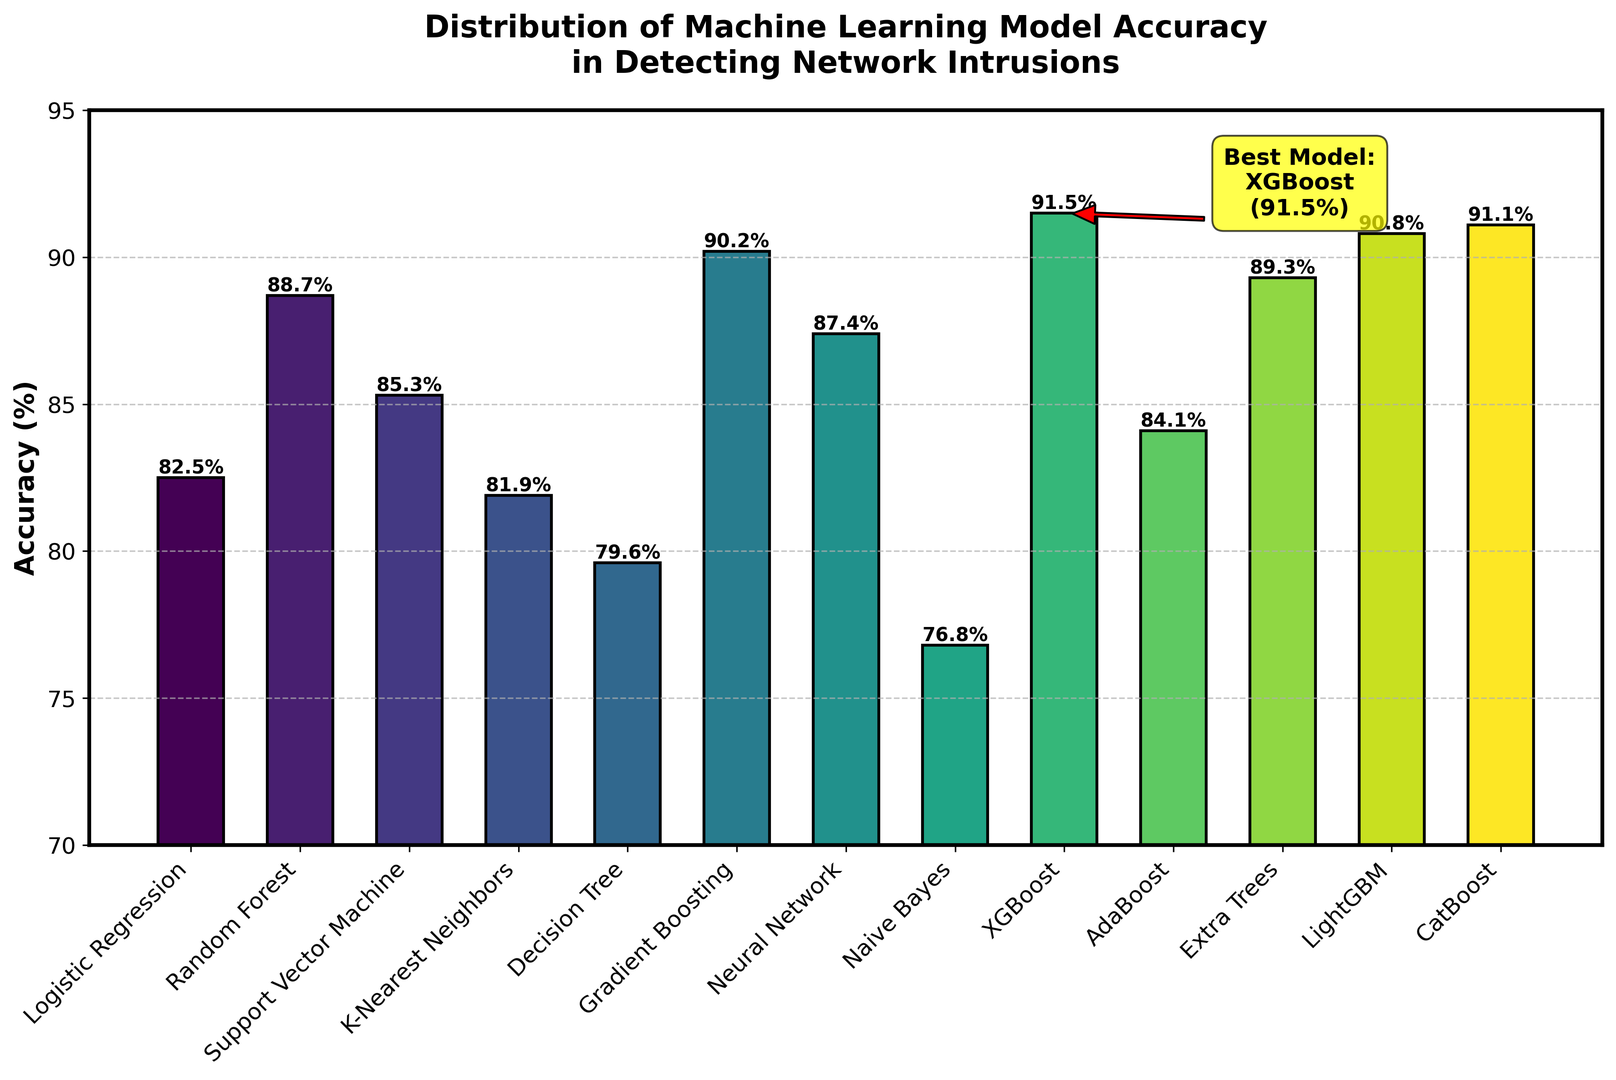Which machine learning model shows the highest accuracy in detecting network intrusions? The figure shows the accuracy for each model, and the annotation highlights the best-performing model. The bar for XGBoost is the tallest, and it's annotated as the best model.
Answer: XGBoost How much higher is the accuracy of XGBoost compared to Naive Bayes? The accuracy of XGBoost is 91.5% and the accuracy of Naive Bayes is 76.8%. The difference is calculated as 91.5% - 76.8%. This gives us the margin.
Answer: 14.7% Which models have an accuracy higher than 90%? By inspecting the figure, we can identify the models: Gradient Boosting (90.2%), XGBoost (91.5%), LightGBM (90.8%), and CatBoost (91.1%) all have accuracies above 90%.
Answer: Gradient Boosting, XGBoost, LightGBM, CatBoost What is the range of accuracies among all models? The range is calculated by subtracting the lowest accuracy from the highest accuracy represented in the figure. XGBoost has the highest accuracy of 91.5% and Naive Bayes has the lowest accuracy of 76.8%.
Answer: 14.7% Is the accuracy of Logistic Regression closer to Decision Tree or K-Nearest Neighbors? Comparing Logistic Regression (82.5%) with Decision Tree (79.6%) and K-Nearest Neighbors (81.9%), we calculate the differences: 82.5% - 79.6% = 2.9% and 82.5% - 81.9% = 0.6%. Logistic Regression is closer to K-Nearest Neighbors.
Answer: K-Nearest Neighbors What is the mean accuracy of all models? The mean can be found by summing all accuracies and dividing by the number of models. Sum = 82.5 + 88.7 + 85.3 + 81.9 + 79.6 + 90.2 + 87.4 + 76.8 + 91.5 + 84.1 + 89.3 + 90.8 + 91.1. There are 13 models, so divide the sum by 13.
Answer: 86.5% How does the accuracy of Neural Network compare to the average accuracy of all models? First, compute the average accuracy (86.5%). Neural Network has an accuracy of 87.4%. Comparing both values, 87.4% is slightly above the average.
Answer: Above average Which models have accuracy within 1% of Gradient Boosting? Gradient Boosting has an accuracy of 90.2%. Within a 1% range are models with accuracies between 89.2% and 91.2%. LightGBM (90.8%), CatBoost (91.1%), and Extra Trees (89.3%) fall within this range.
Answer: LightGBM, CatBoost, Extra Trees Between Random Forest and AdaBoost, which model has higher accuracy and by how much? Random Forest has an accuracy of 88.7%, and AdaBoost has 84.1%. The difference is calculated by 88.7% - 84.1%.
Answer: Random Forest by 4.6% 